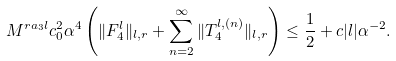<formula> <loc_0><loc_0><loc_500><loc_500>& M ^ { r a _ { 3 } l } c _ { 0 } ^ { 2 } \alpha ^ { 4 } \left ( \| F _ { 4 } ^ { l } \| _ { l , r } + \sum _ { n = 2 } ^ { \infty } \| T _ { 4 } ^ { l , ( n ) } \| _ { l , r } \right ) \leq \frac { 1 } { 2 } + c | l | \alpha ^ { - 2 } .</formula> 